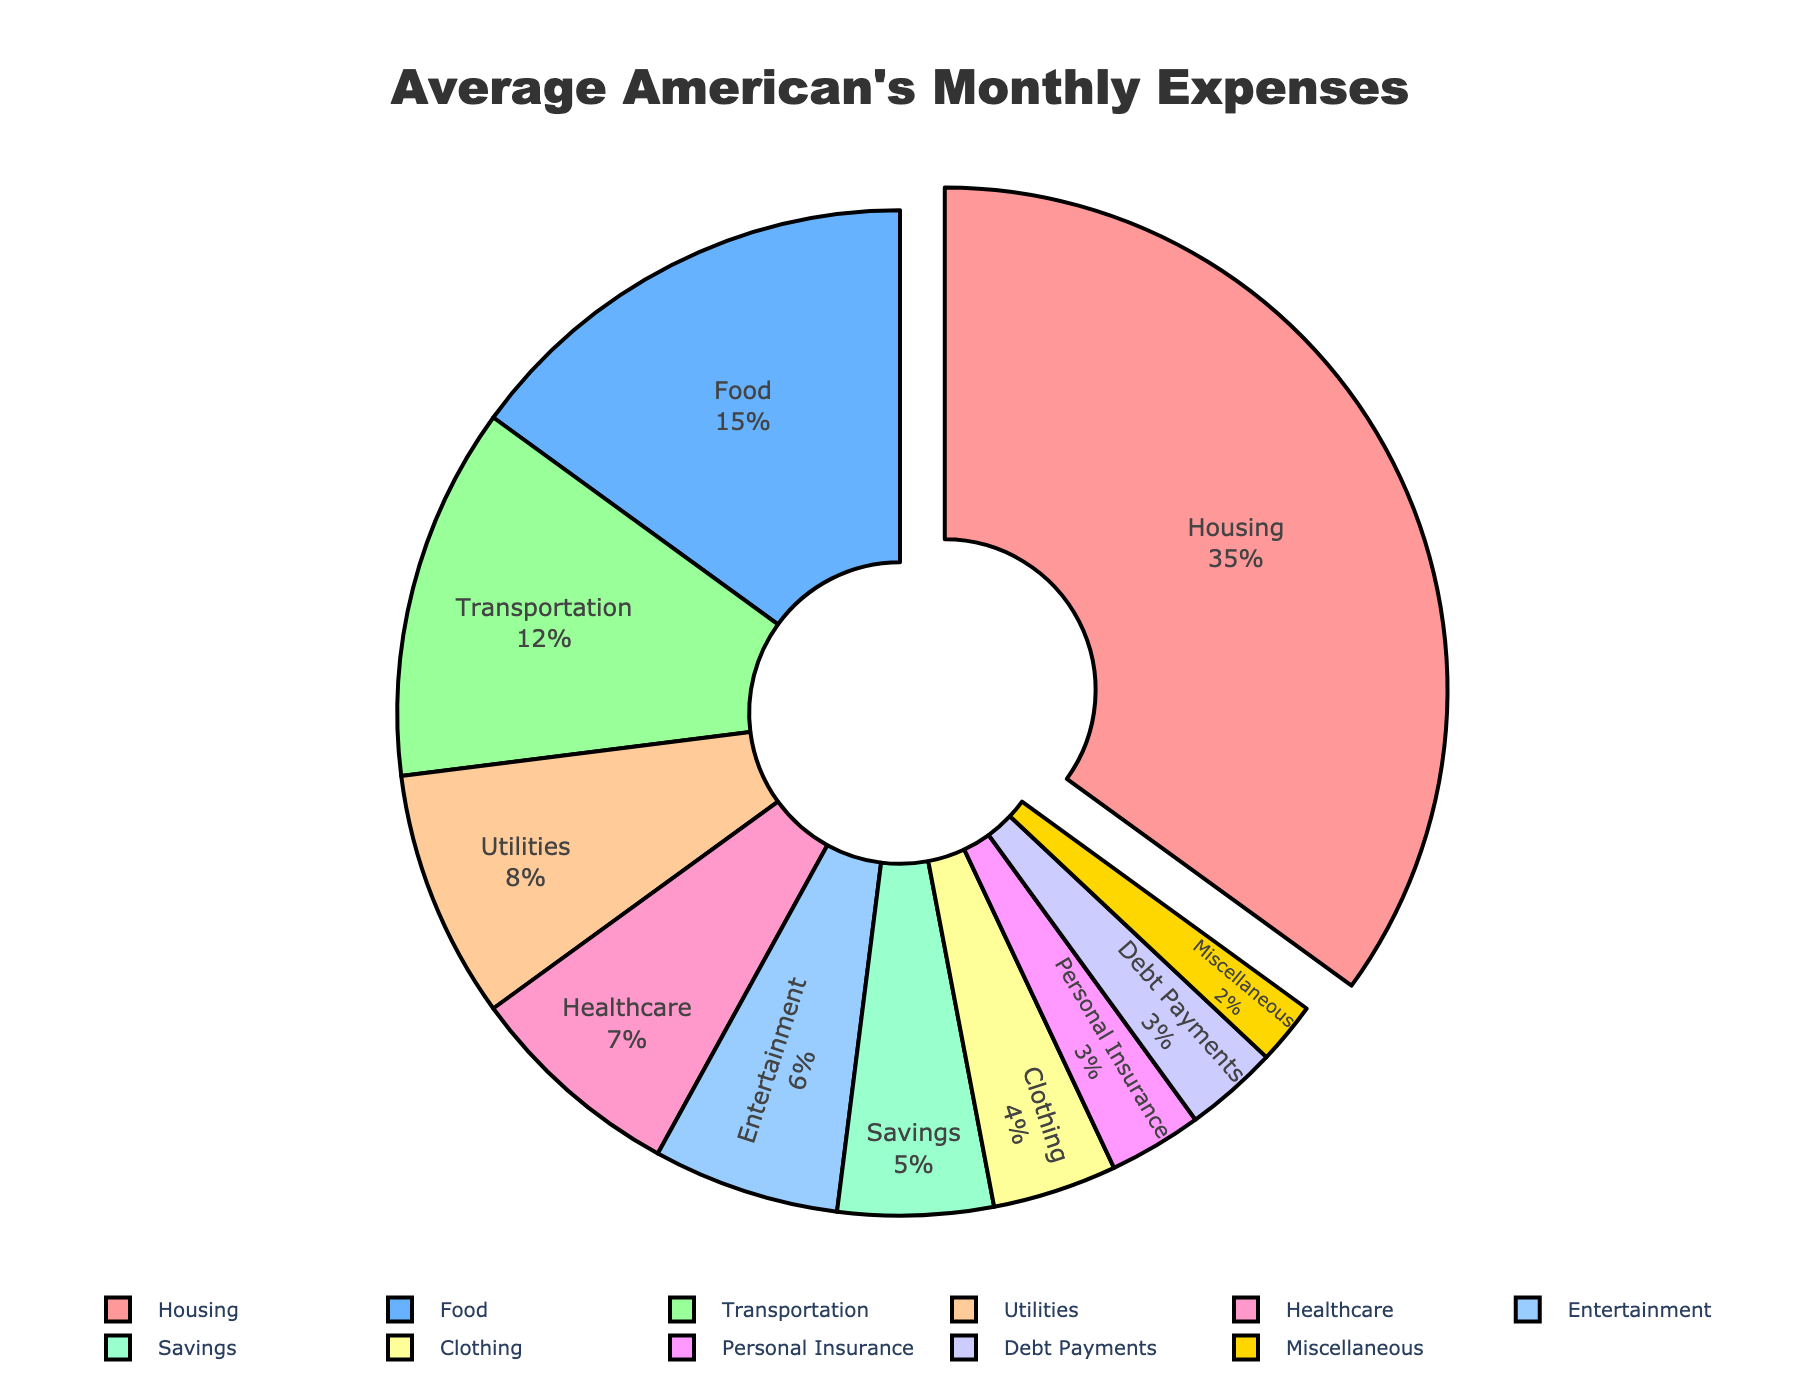Which category has the highest percentage of monthly expenses? The largest section of the pie chart is identified as "Housing" and it stands out because it is distinctly pulled out from the center to emphasize its importance.
Answer: Housing What is the total percentage of monthly expenses accounted for by Food and Transportation combined? The “Food” category has 15% and “Transportation” has 12%. Adding these together gives 15% + 12% = 27%.
Answer: 27% Is the percentage of expenses for Healthcare greater than or equal to the percentage for Entertainment? The "Healthcare" category is 7% while "Entertainment" is 6%. Comparing these values, 7% is indeed greater than 6%.
Answer: Yes What is the percentage difference between the highest and the lowest expense categories? The highest value is Housing at 35% and the lowest is Miscellaneous at 2%. Subtracting these, 35% - 2% = 33%.
Answer: 33% Which categories have percentages less than 5%? The pie chart shows five categories with percentages less than 5%: Clothing (4%), Personal Insurance (3%), Debt Payments (3%), Miscellaneous (2%), and Savings (5%).
Answer: Clothing, Personal Insurance, Debt Payments, Miscellaneous What is the combined percentage of all categories that are 8% or higher? Summing categories that are 8% or higher: Housing (35%), Food (15%), Transportation (12%), and Utilities (8%) gives 35% + 15% + 12% + 8% = 70%.
Answer: 70% How much more is spent on Food compared to Clothing? The pie chart shows Food at 15% and Clothing at 4%. The difference between them is 15% - 4% = 11%.
Answer: 11% What colors represent the Healthcare and Entertainment categories? Healthcare is represented by a pinkish color and Entertainment is represented by a magenta color.
Answer: Pink and magenta Is the percentage for Savings greater than the percentage for Debt Payments? The "Savings" category is at 5% while “Debt Payments” is at 3%. Comparing 5% and 3%, 5% is indeed greater than 3%.
Answer: Yes What is the total percentage if you add Housing, Utilities, and Personal Insurance? The percentages for Housing (35%), Utilities (8%), and Personal Insurance (3%) add up to 35% + 8% + 3% = 46%.
Answer: 46% 